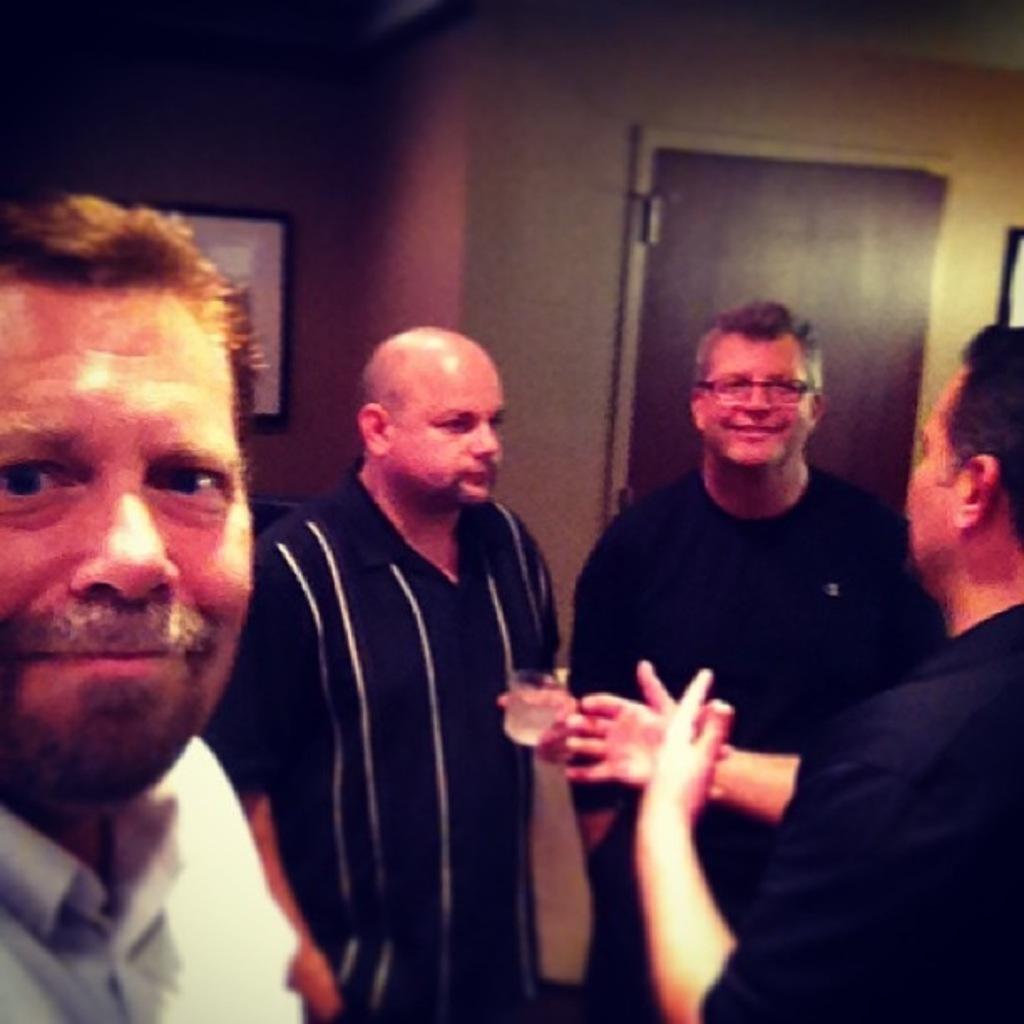In one or two sentences, can you explain what this image depicts? In this picture there are people. In the background of the image we can see a frame on the wall and door. 